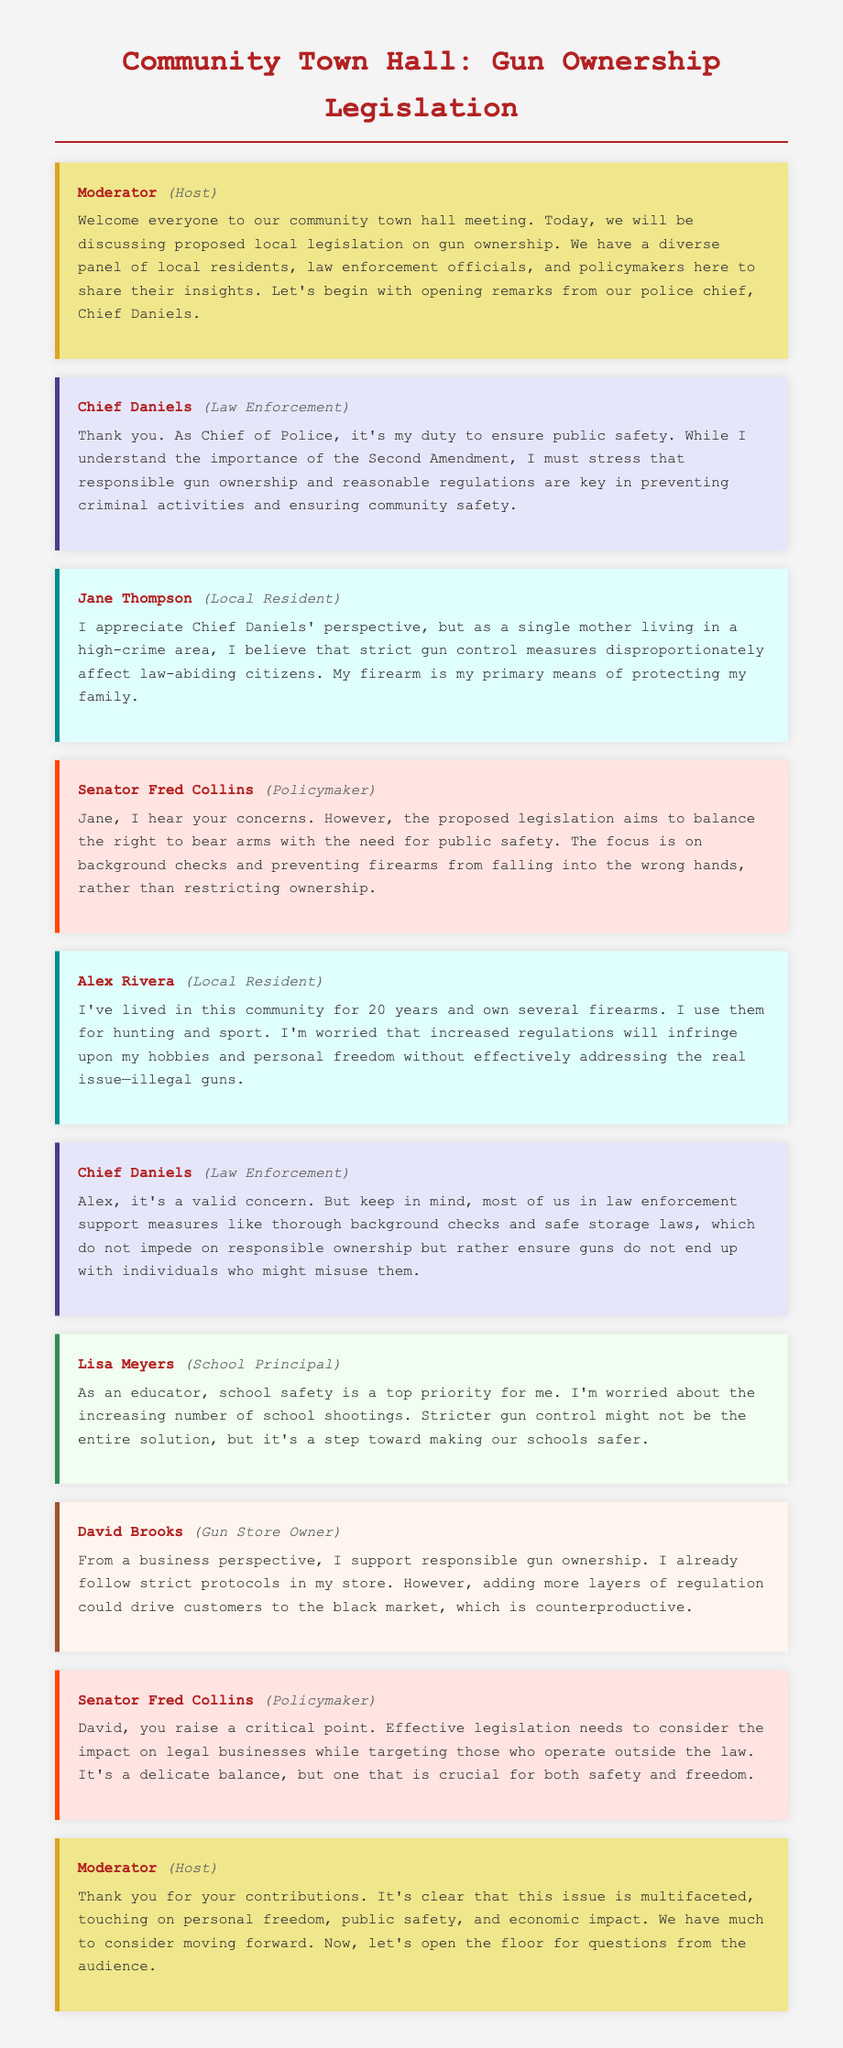What position does Chief Daniels hold? Chief Daniels introduces himself as the Chief of Police, highlighting his role in law enforcement.
Answer: Chief of Police What does Jane Thompson emphasize about gun control measures? Jane Thompson expresses that strict gun control measures affect law-abiding citizens and are essential for her family's protection.
Answer: Affect law-abiding citizens How many years has Alex Rivera lived in the community? Alex Rivera mentions he has lived in the community for twenty years during his testimony.
Answer: Twenty years What is a key point made by Senator Fred Collins regarding the proposed legislation? Senator Fred Collins states that the legislation focuses on balancing the right to bear arms with public safety needs through background checks.
Answer: Balancing rights and safety What concern does Chief Daniels acknowledge regarding increased regulations? Chief Daniels acknowledges that increased regulations are valid concerns while supporting thorough background checks and safe storage laws.
Answer: Valid concerns What key aspect does Lisa Meyers highlight regarding school safety? Lisa Meyers points out her worry about the increasing number of school shootings and the need for steps toward making schools safer.
Answer: Increasing school shootings What business perspective does David Brooks share about regulation? David Brooks notes that adding more regulation could lead customers to the black market, which he considers counterproductive.
Answer: Lead to the black market What does the Moderator conclude about the issue of gun ownership legislation? The Moderator summarizes that the issue touches on personal freedom, public safety, and economic impact, indicating its multifaceted nature.
Answer: Multifaceted nature 